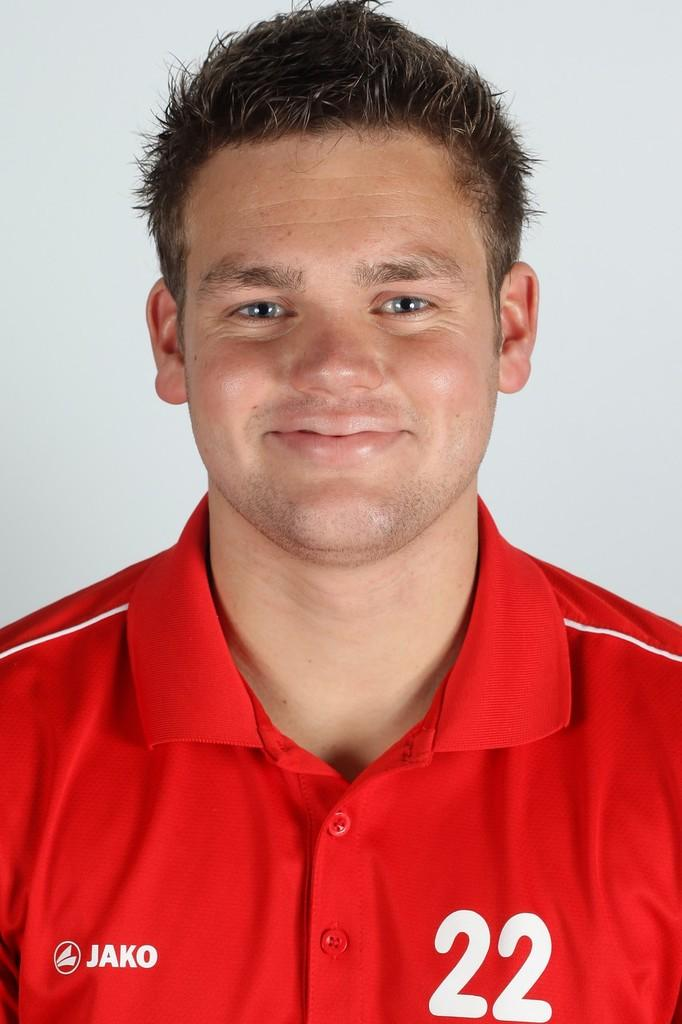Provide a one-sentence caption for the provided image. A close up shot of a man wearing a red jersey with the Jako logo on his chest. 